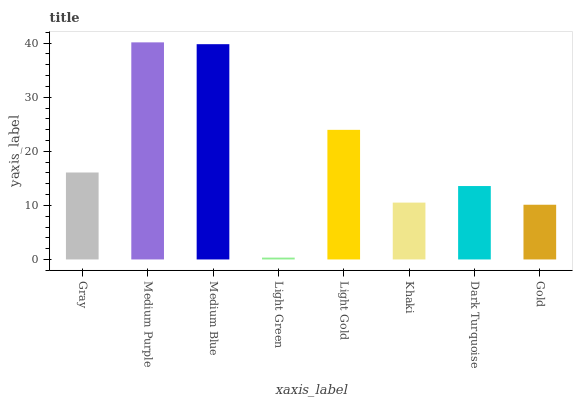Is Light Green the minimum?
Answer yes or no. Yes. Is Medium Purple the maximum?
Answer yes or no. Yes. Is Medium Blue the minimum?
Answer yes or no. No. Is Medium Blue the maximum?
Answer yes or no. No. Is Medium Purple greater than Medium Blue?
Answer yes or no. Yes. Is Medium Blue less than Medium Purple?
Answer yes or no. Yes. Is Medium Blue greater than Medium Purple?
Answer yes or no. No. Is Medium Purple less than Medium Blue?
Answer yes or no. No. Is Gray the high median?
Answer yes or no. Yes. Is Dark Turquoise the low median?
Answer yes or no. Yes. Is Light Green the high median?
Answer yes or no. No. Is Gold the low median?
Answer yes or no. No. 